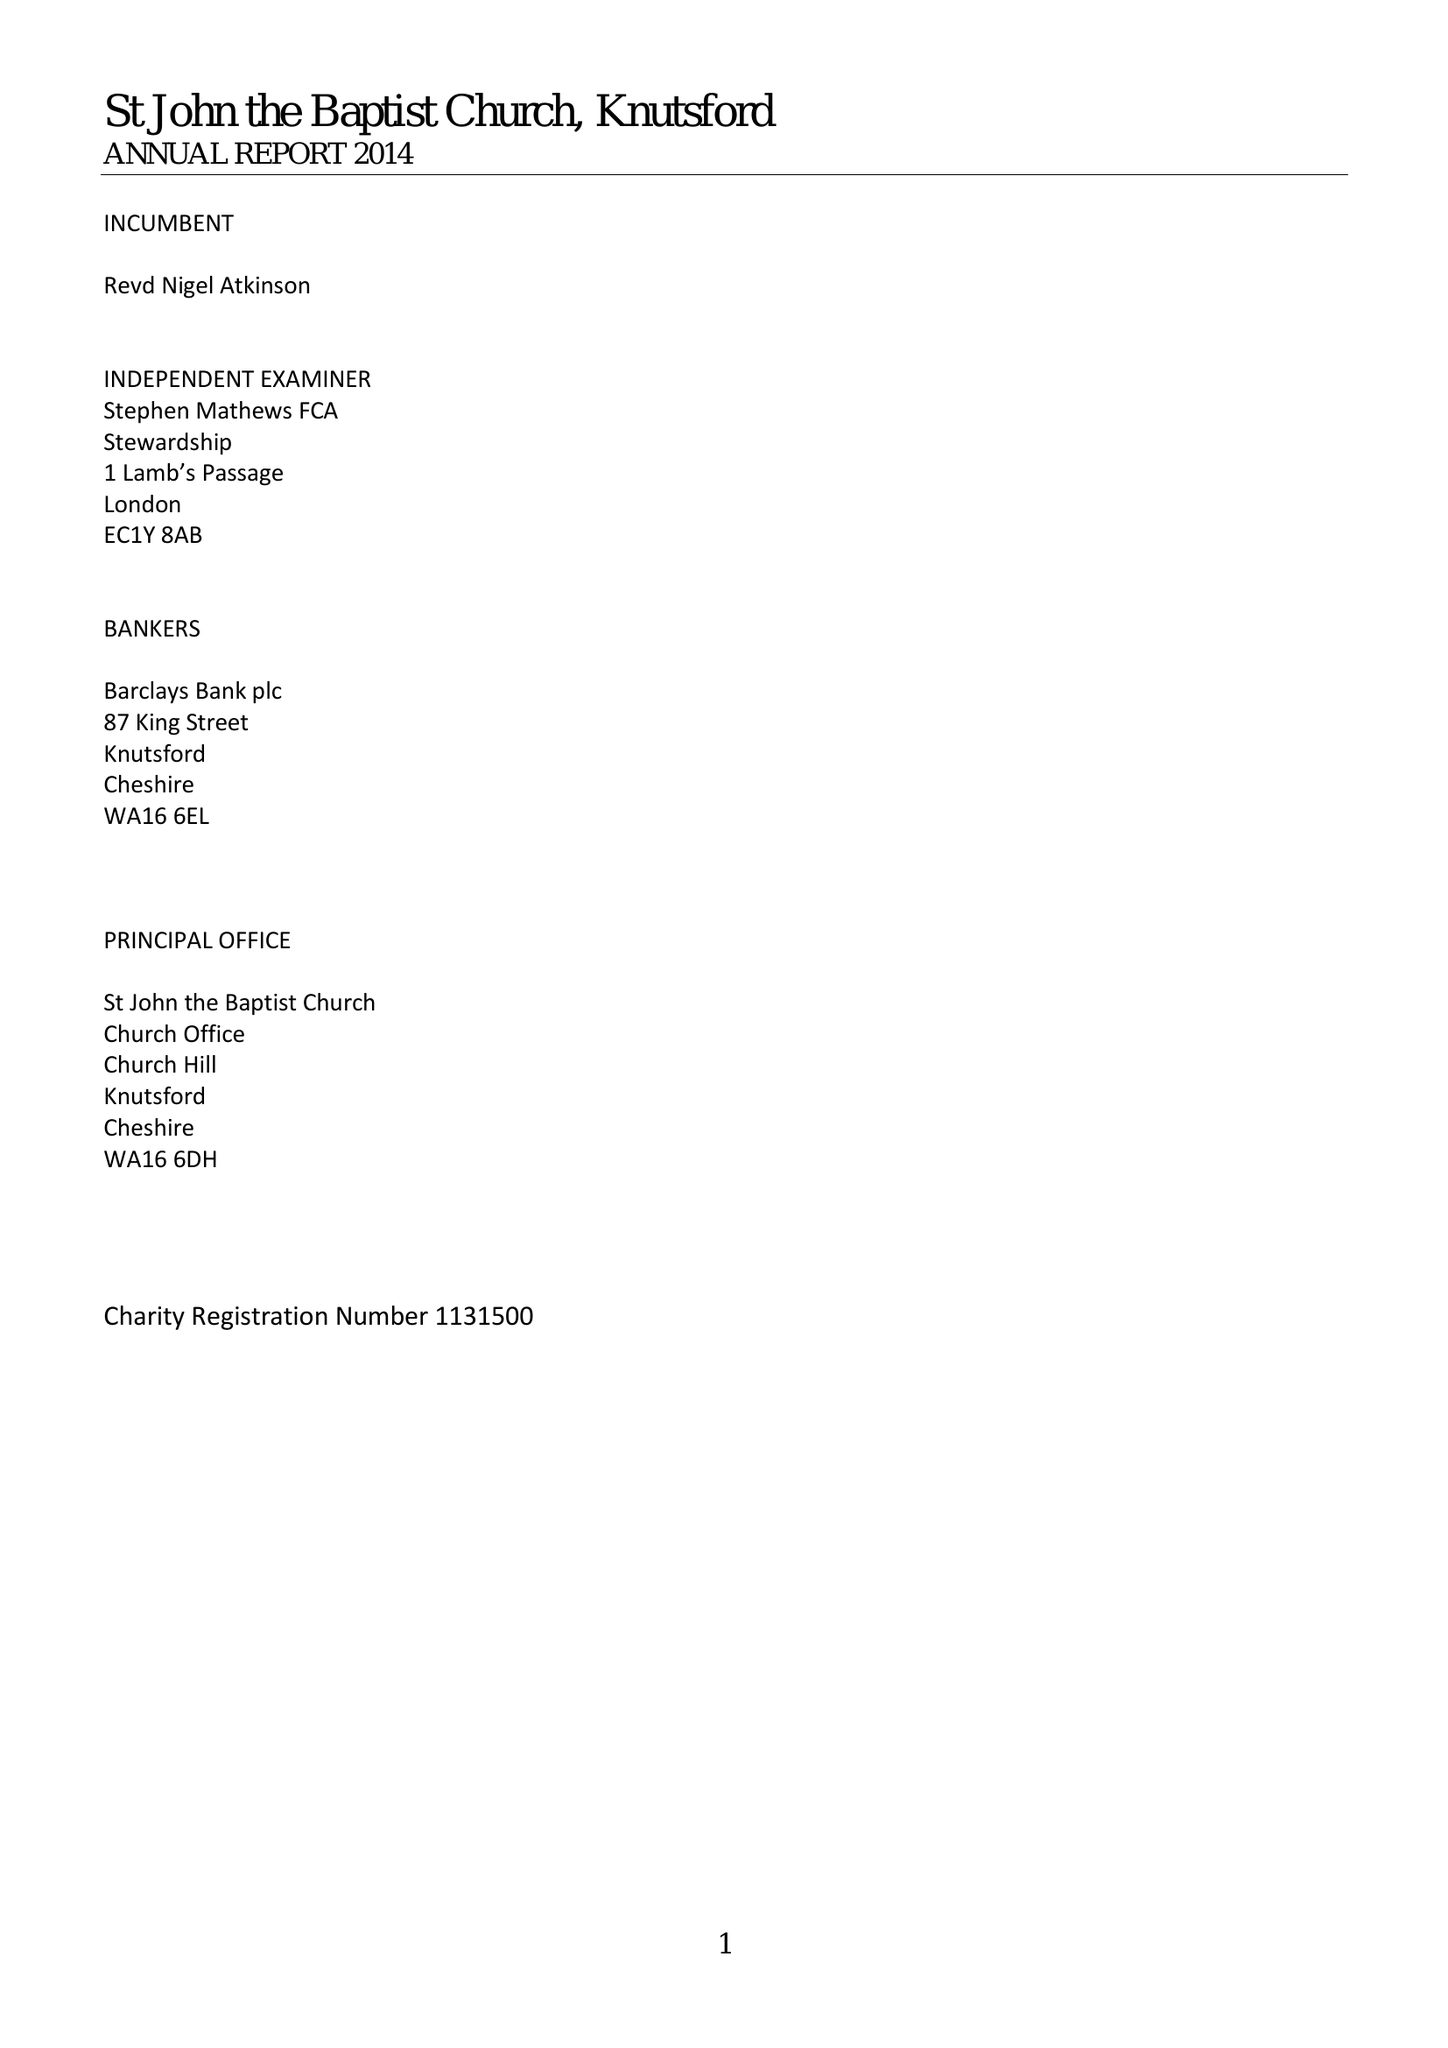What is the value for the charity_number?
Answer the question using a single word or phrase. 1131500 